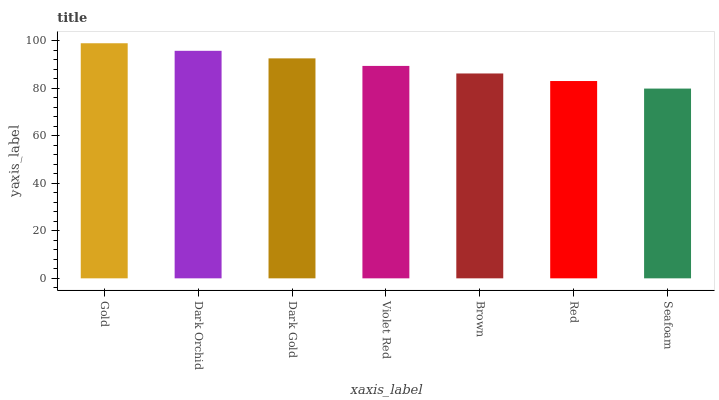Is Seafoam the minimum?
Answer yes or no. Yes. Is Gold the maximum?
Answer yes or no. Yes. Is Dark Orchid the minimum?
Answer yes or no. No. Is Dark Orchid the maximum?
Answer yes or no. No. Is Gold greater than Dark Orchid?
Answer yes or no. Yes. Is Dark Orchid less than Gold?
Answer yes or no. Yes. Is Dark Orchid greater than Gold?
Answer yes or no. No. Is Gold less than Dark Orchid?
Answer yes or no. No. Is Violet Red the high median?
Answer yes or no. Yes. Is Violet Red the low median?
Answer yes or no. Yes. Is Brown the high median?
Answer yes or no. No. Is Dark Gold the low median?
Answer yes or no. No. 